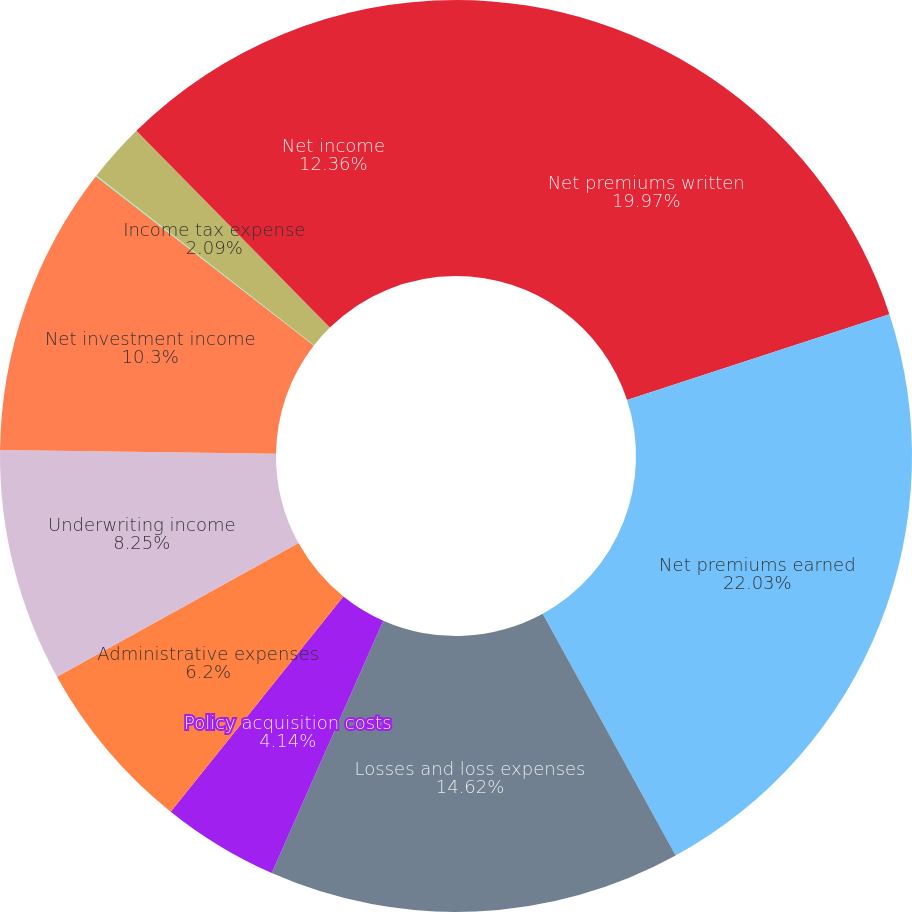Convert chart. <chart><loc_0><loc_0><loc_500><loc_500><pie_chart><fcel>Net premiums written<fcel>Net premiums earned<fcel>Losses and loss expenses<fcel>Policy acquisition costs<fcel>Administrative expenses<fcel>Underwriting income<fcel>Net investment income<fcel>Other (income) expense<fcel>Income tax expense<fcel>Net income<nl><fcel>19.97%<fcel>22.03%<fcel>14.62%<fcel>4.14%<fcel>6.2%<fcel>8.25%<fcel>10.3%<fcel>0.04%<fcel>2.09%<fcel>12.36%<nl></chart> 